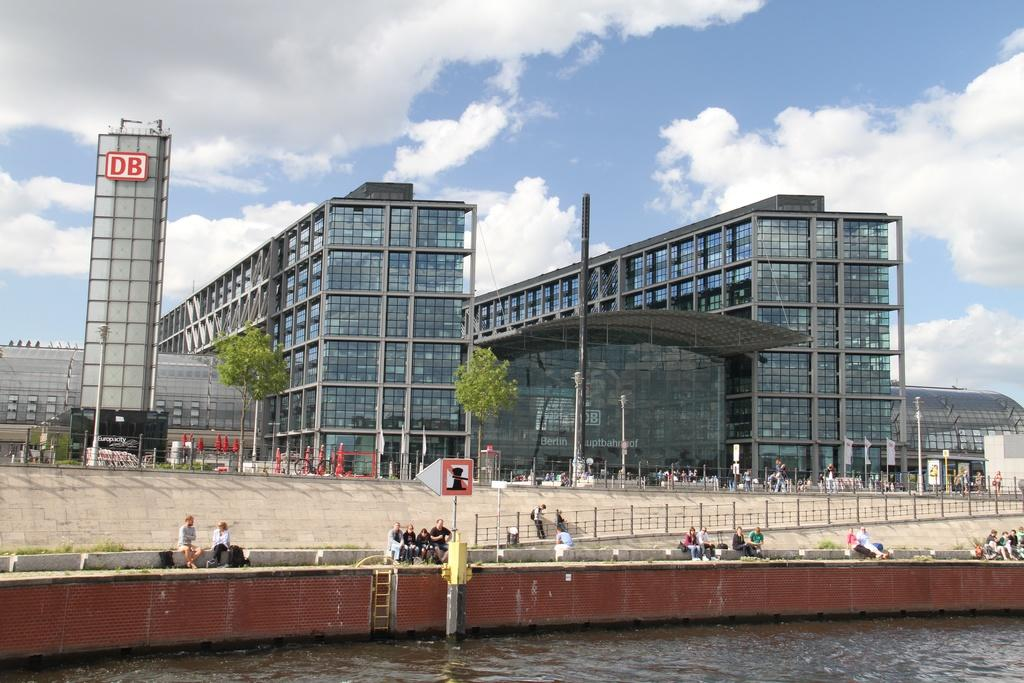What is the weather condition in the image? The sky is cloudy in the image. What type of buildings can be seen in the image? The buildings have glass windows. What natural element is visible in the image? There is water visible in the image. What type of barrier is present in the image? There is a fence in the image. Are there any people in the image? Yes, there are people in the image. What type of signage is present in the image? There is a sign board in the image. What type of vegetation is near the buildings? Trees are present near the buildings. What type of decoration or symbol is visible near the buildings? Flags are visible near the buildings. What type of card is being used to plough the field in the image? There is no card or field present in the image. What type of hammer is being used to fix the fence in the image? There is no hammer or activity of fixing the fence in the image. 